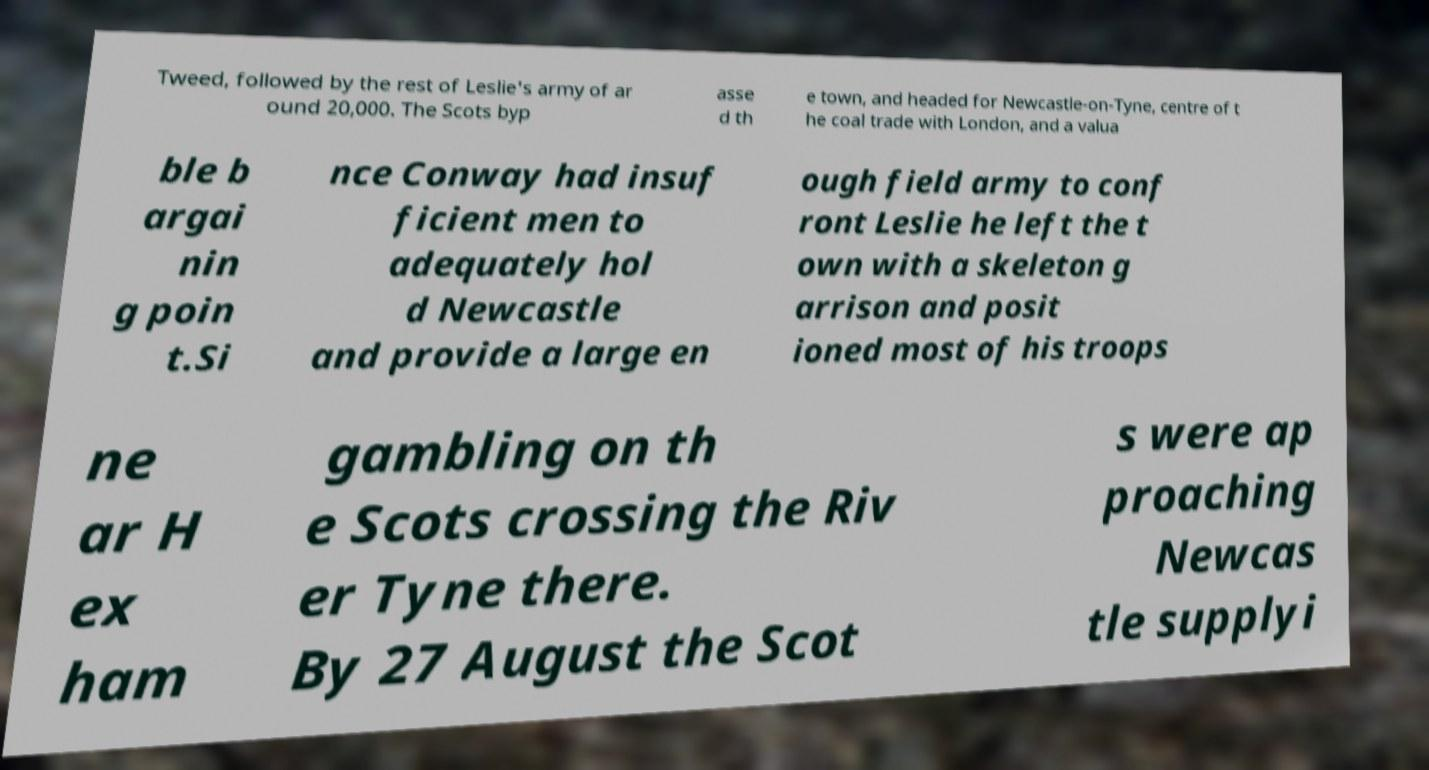Could you extract and type out the text from this image? Tweed, followed by the rest of Leslie's army of ar ound 20,000. The Scots byp asse d th e town, and headed for Newcastle-on-Tyne, centre of t he coal trade with London, and a valua ble b argai nin g poin t.Si nce Conway had insuf ficient men to adequately hol d Newcastle and provide a large en ough field army to conf ront Leslie he left the t own with a skeleton g arrison and posit ioned most of his troops ne ar H ex ham gambling on th e Scots crossing the Riv er Tyne there. By 27 August the Scot s were ap proaching Newcas tle supplyi 